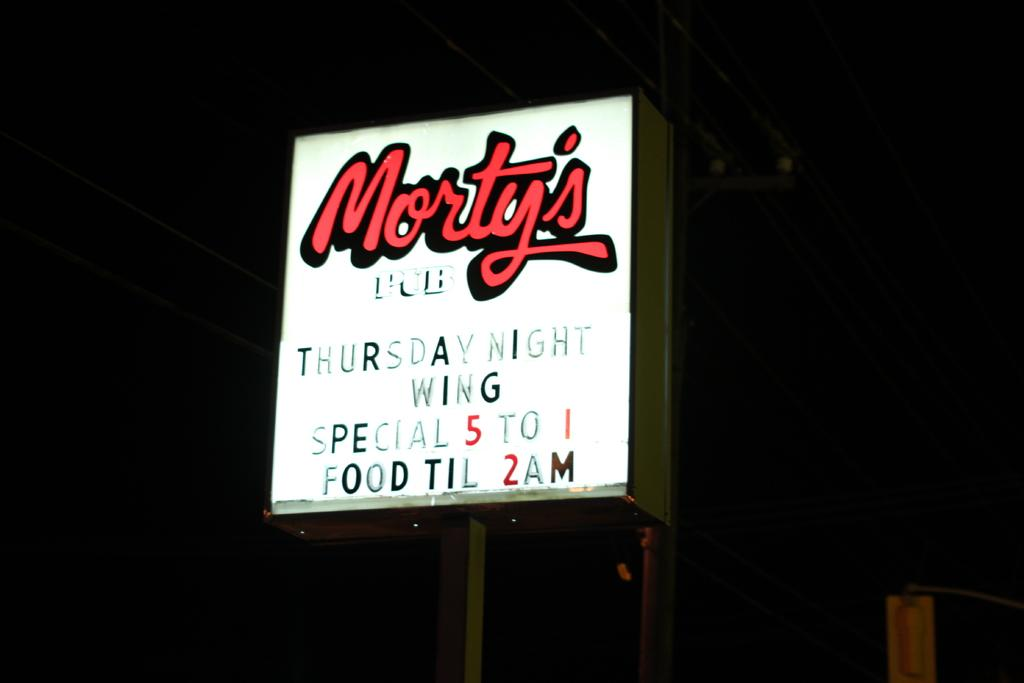What is the main object in the image? There is a hoarding board in the image. What else can be seen in the image besides the hoarding board? There is a pole in the image. What is the color of the background in the image? The background of the image is dark. What type of amusement can be seen on the furniture in the image? There is no furniture present in the image, and therefore no amusement can be observed. 